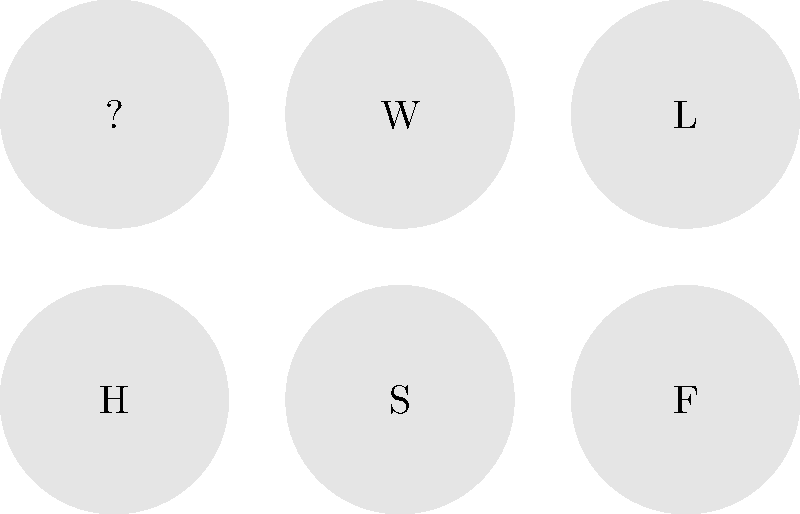Which literary character is represented by the icon labeled "H"? Let's break this down step-by-step:

1. The image shows six circular icons, each containing a single letter.
2. We're asked about the icon labeled "H".
3. In literature, characters are often represented by their initials.
4. "H" could stand for many characters, but we need to think of well-known, iconic figures that might be familiar even to someone who finds most books intimidating.
5. One of the most famous and accessible literary characters with the initial "H" is Harry Potter.
6. Harry Potter is a character from a series that's particularly popular among younger readers and has been adapted into movies, making it less intimidating for those who might not read much.
7. Given the persona of a Gen Z woman who's interested in reading but finds most books intimidating, Harry Potter would be a likely character she'd recognize.

Therefore, the most probable answer is that "H" represents Harry Potter.
Answer: Harry Potter 